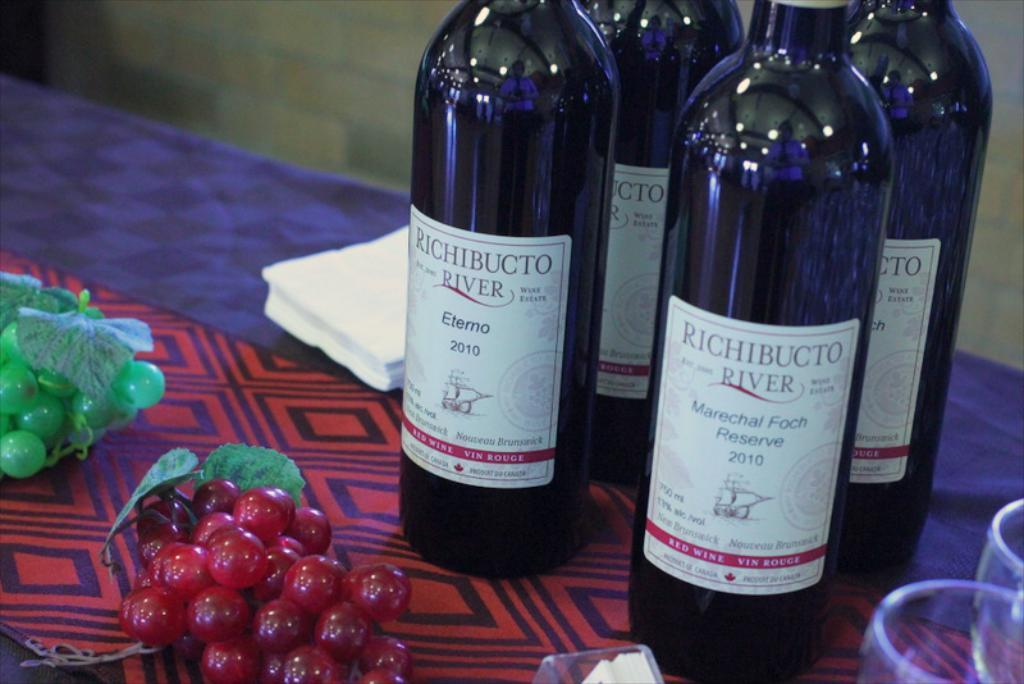<image>
Describe the image concisely. The four bottles of Richibucto River were on top of the table. 